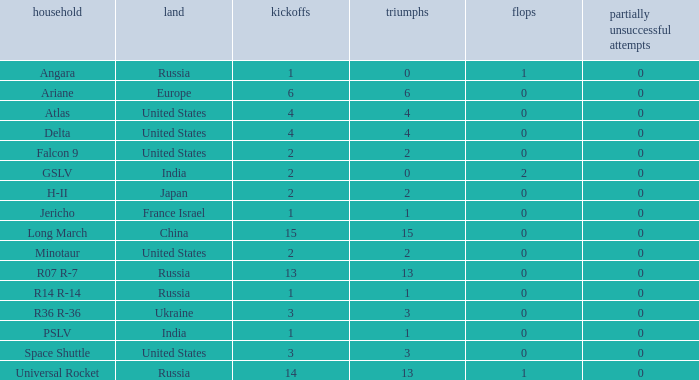What is the partial failure for the Country of russia, and a Failure larger than 0, and a Family of angara, and a Launch larger than 1? None. 